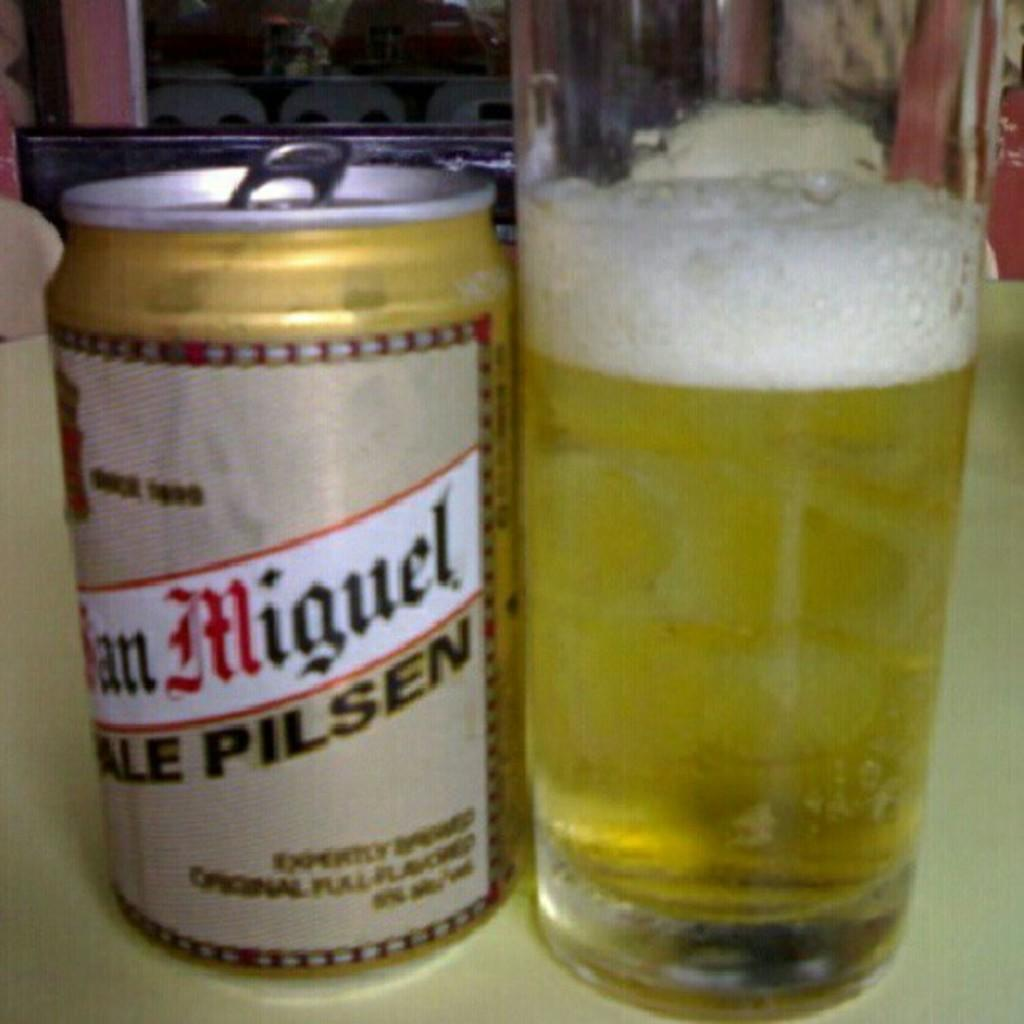<image>
Describe the image concisely. A glass and a bottle of miguel beer sitting on a table. 